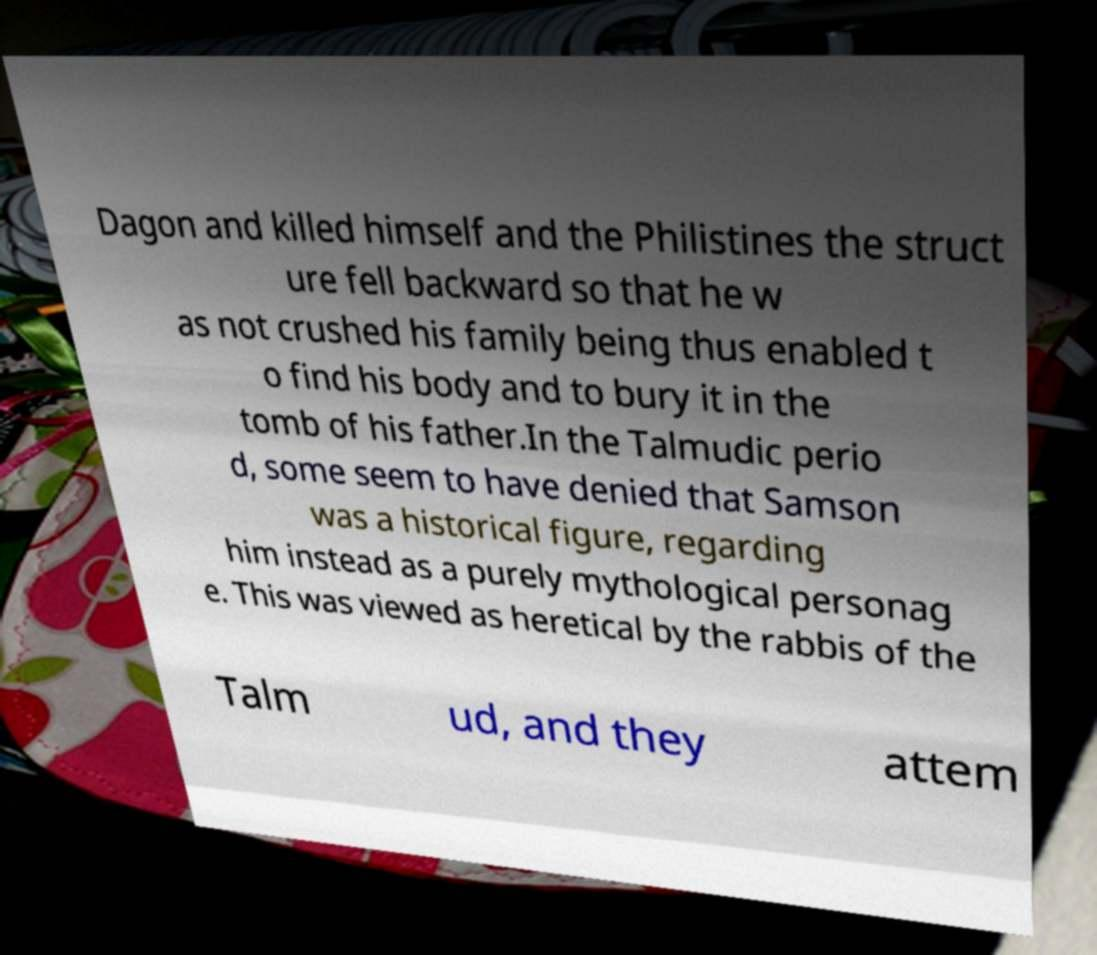Can you read and provide the text displayed in the image?This photo seems to have some interesting text. Can you extract and type it out for me? Dagon and killed himself and the Philistines the struct ure fell backward so that he w as not crushed his family being thus enabled t o find his body and to bury it in the tomb of his father.In the Talmudic perio d, some seem to have denied that Samson was a historical figure, regarding him instead as a purely mythological personag e. This was viewed as heretical by the rabbis of the Talm ud, and they attem 